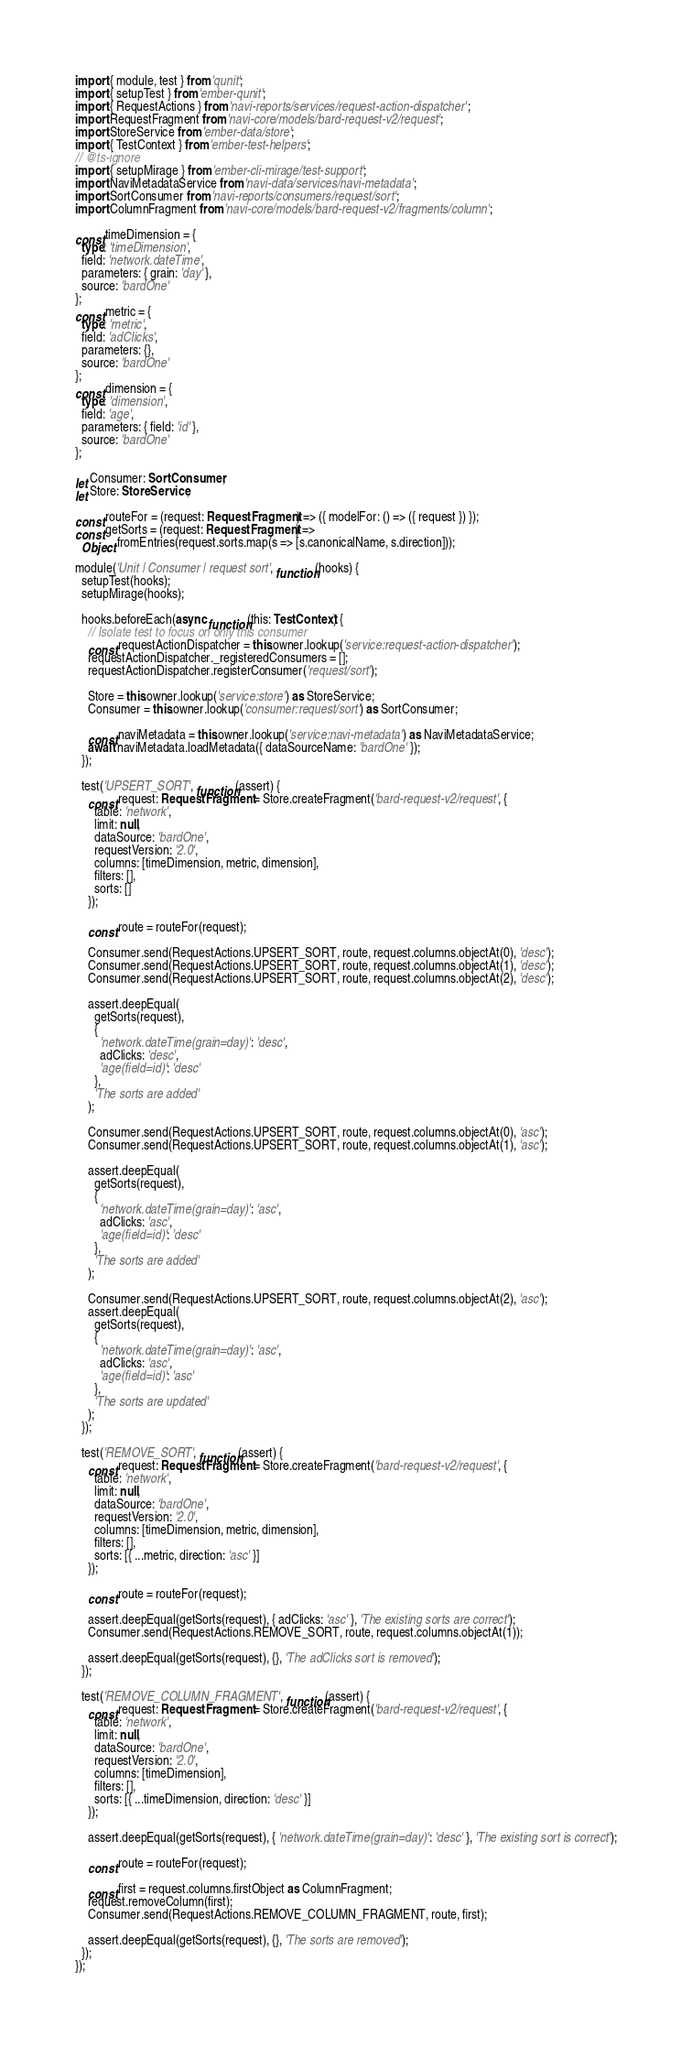<code> <loc_0><loc_0><loc_500><loc_500><_TypeScript_>import { module, test } from 'qunit';
import { setupTest } from 'ember-qunit';
import { RequestActions } from 'navi-reports/services/request-action-dispatcher';
import RequestFragment from 'navi-core/models/bard-request-v2/request';
import StoreService from 'ember-data/store';
import { TestContext } from 'ember-test-helpers';
// @ts-ignore
import { setupMirage } from 'ember-cli-mirage/test-support';
import NaviMetadataService from 'navi-data/services/navi-metadata';
import SortConsumer from 'navi-reports/consumers/request/sort';
import ColumnFragment from 'navi-core/models/bard-request-v2/fragments/column';

const timeDimension = {
  type: 'timeDimension',
  field: 'network.dateTime',
  parameters: { grain: 'day' },
  source: 'bardOne'
};
const metric = {
  type: 'metric',
  field: 'adClicks',
  parameters: {},
  source: 'bardOne'
};
const dimension = {
  type: 'dimension',
  field: 'age',
  parameters: { field: 'id' },
  source: 'bardOne'
};

let Consumer: SortConsumer;
let Store: StoreService;

const routeFor = (request: RequestFragment) => ({ modelFor: () => ({ request }) });
const getSorts = (request: RequestFragment) =>
  Object.fromEntries(request.sorts.map(s => [s.canonicalName, s.direction]));

module('Unit | Consumer | request sort', function(hooks) {
  setupTest(hooks);
  setupMirage(hooks);

  hooks.beforeEach(async function(this: TestContext) {
    // Isolate test to focus on only this consumer
    const requestActionDispatcher = this.owner.lookup('service:request-action-dispatcher');
    requestActionDispatcher._registeredConsumers = [];
    requestActionDispatcher.registerConsumer('request/sort');

    Store = this.owner.lookup('service:store') as StoreService;
    Consumer = this.owner.lookup('consumer:request/sort') as SortConsumer;

    const naviMetadata = this.owner.lookup('service:navi-metadata') as NaviMetadataService;
    await naviMetadata.loadMetadata({ dataSourceName: 'bardOne' });
  });

  test('UPSERT_SORT', function(assert) {
    const request: RequestFragment = Store.createFragment('bard-request-v2/request', {
      table: 'network',
      limit: null,
      dataSource: 'bardOne',
      requestVersion: '2.0',
      columns: [timeDimension, metric, dimension],
      filters: [],
      sorts: []
    });

    const route = routeFor(request);

    Consumer.send(RequestActions.UPSERT_SORT, route, request.columns.objectAt(0), 'desc');
    Consumer.send(RequestActions.UPSERT_SORT, route, request.columns.objectAt(1), 'desc');
    Consumer.send(RequestActions.UPSERT_SORT, route, request.columns.objectAt(2), 'desc');

    assert.deepEqual(
      getSorts(request),
      {
        'network.dateTime(grain=day)': 'desc',
        adClicks: 'desc',
        'age(field=id)': 'desc'
      },
      'The sorts are added'
    );

    Consumer.send(RequestActions.UPSERT_SORT, route, request.columns.objectAt(0), 'asc');
    Consumer.send(RequestActions.UPSERT_SORT, route, request.columns.objectAt(1), 'asc');

    assert.deepEqual(
      getSorts(request),
      {
        'network.dateTime(grain=day)': 'asc',
        adClicks: 'asc',
        'age(field=id)': 'desc'
      },
      'The sorts are added'
    );

    Consumer.send(RequestActions.UPSERT_SORT, route, request.columns.objectAt(2), 'asc');
    assert.deepEqual(
      getSorts(request),
      {
        'network.dateTime(grain=day)': 'asc',
        adClicks: 'asc',
        'age(field=id)': 'asc'
      },
      'The sorts are updated'
    );
  });

  test('REMOVE_SORT', function(assert) {
    const request: RequestFragment = Store.createFragment('bard-request-v2/request', {
      table: 'network',
      limit: null,
      dataSource: 'bardOne',
      requestVersion: '2.0',
      columns: [timeDimension, metric, dimension],
      filters: [],
      sorts: [{ ...metric, direction: 'asc' }]
    });

    const route = routeFor(request);

    assert.deepEqual(getSorts(request), { adClicks: 'asc' }, 'The existing sorts are correct');
    Consumer.send(RequestActions.REMOVE_SORT, route, request.columns.objectAt(1));

    assert.deepEqual(getSorts(request), {}, 'The adClicks sort is removed');
  });

  test('REMOVE_COLUMN_FRAGMENT', function(assert) {
    const request: RequestFragment = Store.createFragment('bard-request-v2/request', {
      table: 'network',
      limit: null,
      dataSource: 'bardOne',
      requestVersion: '2.0',
      columns: [timeDimension],
      filters: [],
      sorts: [{ ...timeDimension, direction: 'desc' }]
    });

    assert.deepEqual(getSorts(request), { 'network.dateTime(grain=day)': 'desc' }, 'The existing sort is correct');

    const route = routeFor(request);

    const first = request.columns.firstObject as ColumnFragment;
    request.removeColumn(first);
    Consumer.send(RequestActions.REMOVE_COLUMN_FRAGMENT, route, first);

    assert.deepEqual(getSorts(request), {}, 'The sorts are removed');
  });
});
</code> 